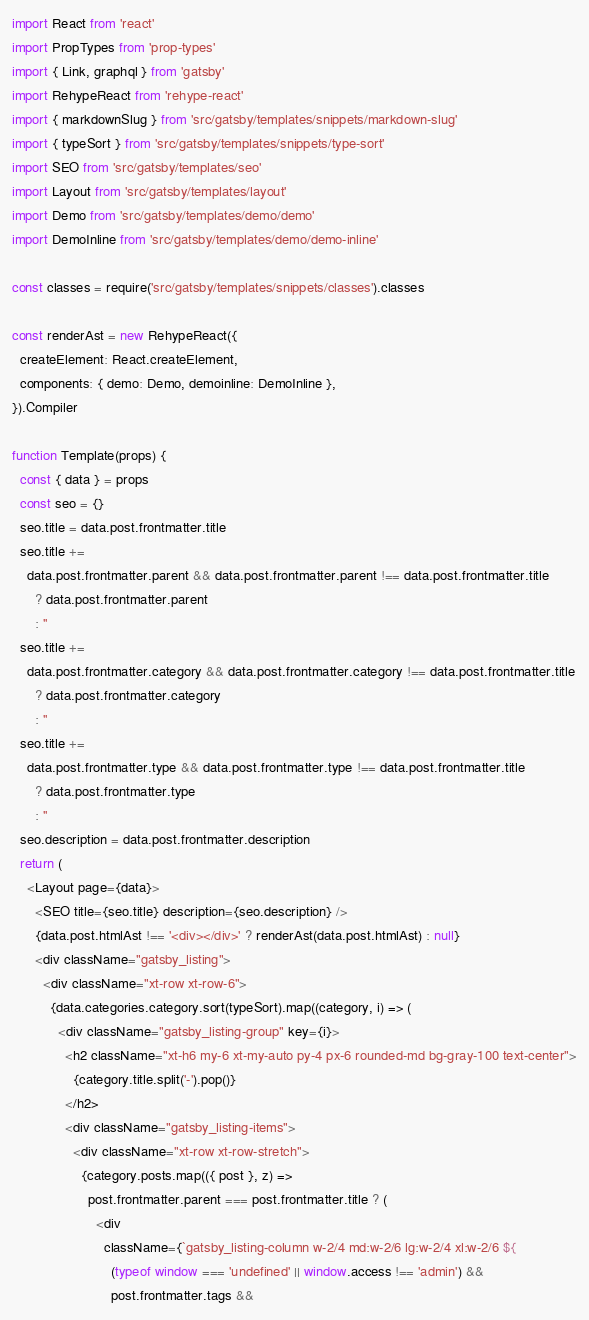Convert code to text. <code><loc_0><loc_0><loc_500><loc_500><_JavaScript_>import React from 'react'
import PropTypes from 'prop-types'
import { Link, graphql } from 'gatsby'
import RehypeReact from 'rehype-react'
import { markdownSlug } from 'src/gatsby/templates/snippets/markdown-slug'
import { typeSort } from 'src/gatsby/templates/snippets/type-sort'
import SEO from 'src/gatsby/templates/seo'
import Layout from 'src/gatsby/templates/layout'
import Demo from 'src/gatsby/templates/demo/demo'
import DemoInline from 'src/gatsby/templates/demo/demo-inline'

const classes = require('src/gatsby/templates/snippets/classes').classes

const renderAst = new RehypeReact({
  createElement: React.createElement,
  components: { demo: Demo, demoinline: DemoInline },
}).Compiler

function Template(props) {
  const { data } = props
  const seo = {}
  seo.title = data.post.frontmatter.title
  seo.title +=
    data.post.frontmatter.parent && data.post.frontmatter.parent !== data.post.frontmatter.title
      ? data.post.frontmatter.parent
      : ''
  seo.title +=
    data.post.frontmatter.category && data.post.frontmatter.category !== data.post.frontmatter.title
      ? data.post.frontmatter.category
      : ''
  seo.title +=
    data.post.frontmatter.type && data.post.frontmatter.type !== data.post.frontmatter.title
      ? data.post.frontmatter.type
      : ''
  seo.description = data.post.frontmatter.description
  return (
    <Layout page={data}>
      <SEO title={seo.title} description={seo.description} />
      {data.post.htmlAst !== '<div></div>' ? renderAst(data.post.htmlAst) : null}
      <div className="gatsby_listing">
        <div className="xt-row xt-row-6">
          {data.categories.category.sort(typeSort).map((category, i) => (
            <div className="gatsby_listing-group" key={i}>
              <h2 className="xt-h6 my-6 xt-my-auto py-4 px-6 rounded-md bg-gray-100 text-center">
                {category.title.split('-').pop()}
              </h2>
              <div className="gatsby_listing-items">
                <div className="xt-row xt-row-stretch">
                  {category.posts.map(({ post }, z) =>
                    post.frontmatter.parent === post.frontmatter.title ? (
                      <div
                        className={`gatsby_listing-column w-2/4 md:w-2/6 lg:w-2/4 xl:w-2/6 ${
                          (typeof window === 'undefined' || window.access !== 'admin') &&
                          post.frontmatter.tags &&</code> 